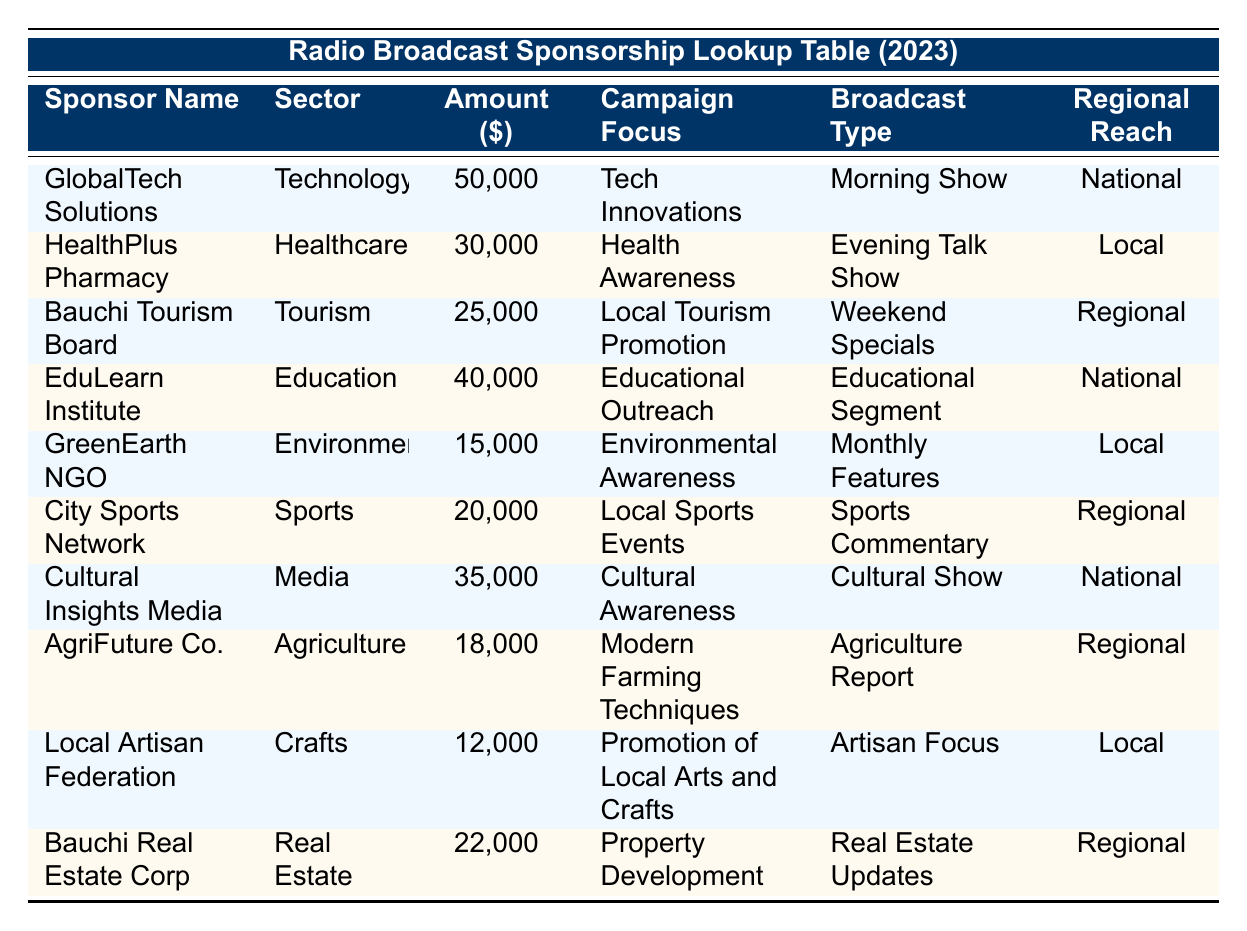What is the sponsorship amount from GlobalTech Solutions? The table shows that GlobalTech Solutions has a sponsorship amount listed under the "Amount ($)" column. The value corresponding to GlobalTech Solutions is 50,000.
Answer: 50,000 How many sponsors have a regional reach of "Local"? Looking through the "Regional Reach" column, the sponsors categorized as "Local" are HealthPlus Pharmacy, GreenEarth NGO, and Local Artisan Federation. That totals to 3 sponsors.
Answer: 3 What is the total sponsorship amount from sponsors focused on the Education sector? The table indicates that EduLearn Institute is the only sponsor in the Education sector, contributing a sponsorship amount of 40,000. Since there's just one sponsor, the total is 40,000.
Answer: 40,000 Is there a sponsor whose campaign focus is "Health Awareness"? By scanning the "Campaign Focus" column, it can be seen that HealthPlus Pharmacy has a campaign focus of "Health Awareness." This confirms that there is indeed a sponsor with that focus.
Answer: Yes What is the average sponsorship amount of all sponsors? To calculate the average, first sum all the sponsorship amounts: 50,000 + 30,000 + 25,000 + 40,000 + 15,000 + 20,000 + 35,000 + 18,000 + 12,000 + 22,000 = 252,000. There are 10 sponsors, so average = 252,000 / 10 = 25,200.
Answer: 25,200 Which sponsor in the Agriculture sector has the lowest sponsorship amount? The table shows that AgriFuture Co. is the only sponsor listed in the Agriculture sector with a sponsorship amount of 18,000, which is the lowest for that sector.
Answer: AgriFuture Co Are there any sponsors who focus on "Cultural Awareness" and what is their amount? Upon checking the "Campaign Focus" column, Cultural Insights Media is found to focus on "Cultural Awareness," with a sponsorship amount of 35,000.
Answer: Cultural Insights Media, 35,000 What is the difference between the highest and lowest sponsorship amounts? The highest sponsorship amount is 50,000 from GlobalTech Solutions, while the lowest is 12,000 from Local Artisan Federation. The difference is calculated as 50,000 - 12,000 = 38,000.
Answer: 38,000 How many different sectors are represented by the sponsors? By analyzing the "Sector" column for unique entries, the sectors include Technology, Healthcare, Tourism, Education, Environment, Sports, Media, Agriculture, Crafts, and Real Estate, totaling 10 distinct sectors.
Answer: 10 